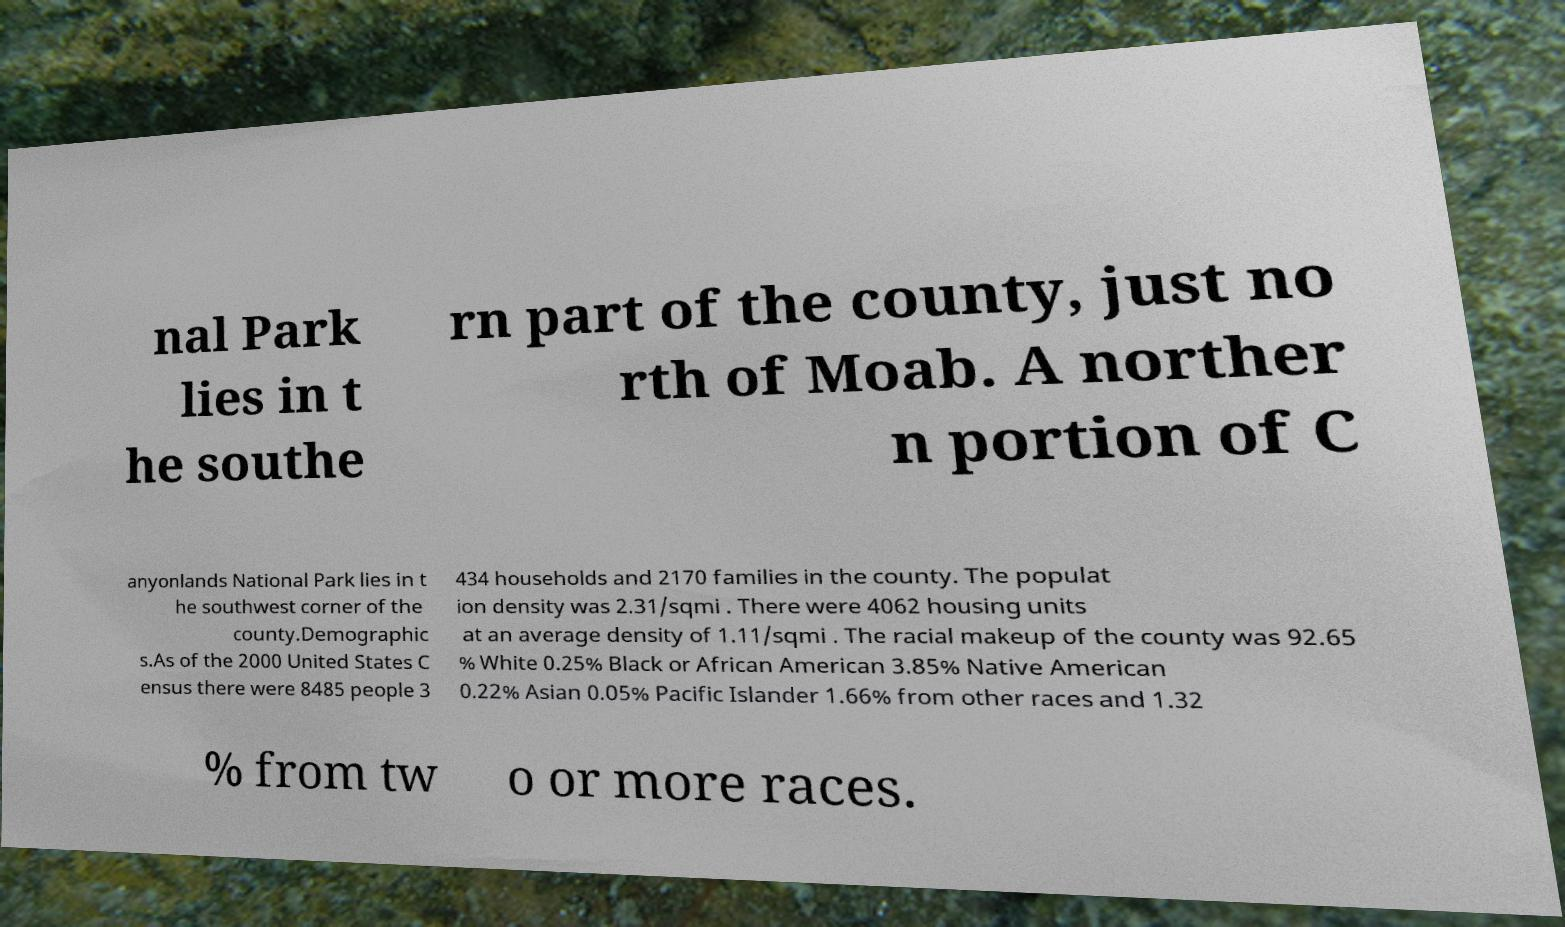What messages or text are displayed in this image? I need them in a readable, typed format. nal Park lies in t he southe rn part of the county, just no rth of Moab. A norther n portion of C anyonlands National Park lies in t he southwest corner of the county.Demographic s.As of the 2000 United States C ensus there were 8485 people 3 434 households and 2170 families in the county. The populat ion density was 2.31/sqmi . There were 4062 housing units at an average density of 1.11/sqmi . The racial makeup of the county was 92.65 % White 0.25% Black or African American 3.85% Native American 0.22% Asian 0.05% Pacific Islander 1.66% from other races and 1.32 % from tw o or more races. 